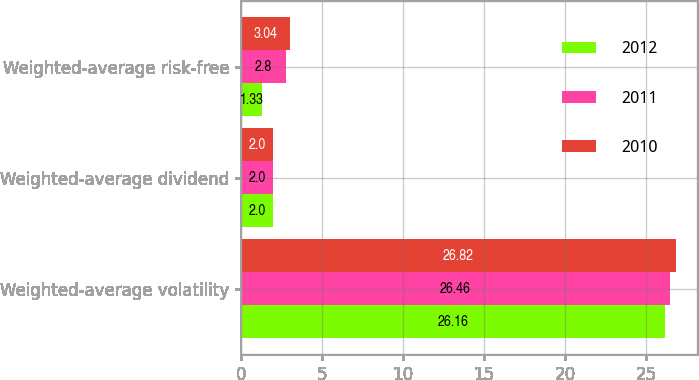<chart> <loc_0><loc_0><loc_500><loc_500><stacked_bar_chart><ecel><fcel>Weighted-average volatility<fcel>Weighted-average dividend<fcel>Weighted-average risk-free<nl><fcel>2012<fcel>26.16<fcel>2<fcel>1.33<nl><fcel>2011<fcel>26.46<fcel>2<fcel>2.8<nl><fcel>2010<fcel>26.82<fcel>2<fcel>3.04<nl></chart> 